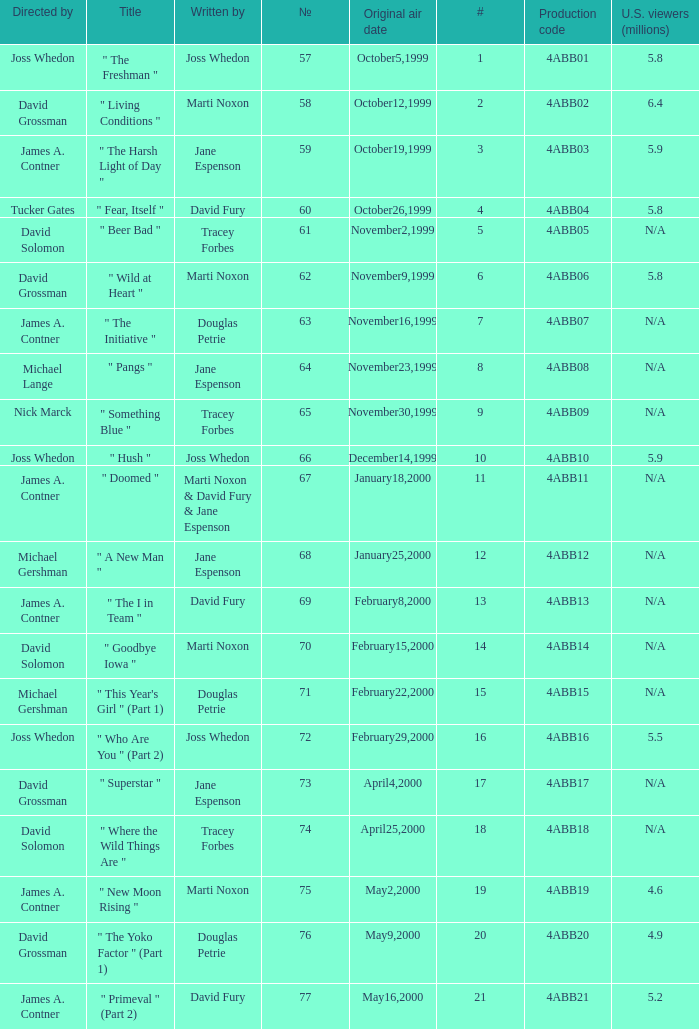What is the series No when the season 4 # is 18? 74.0. 